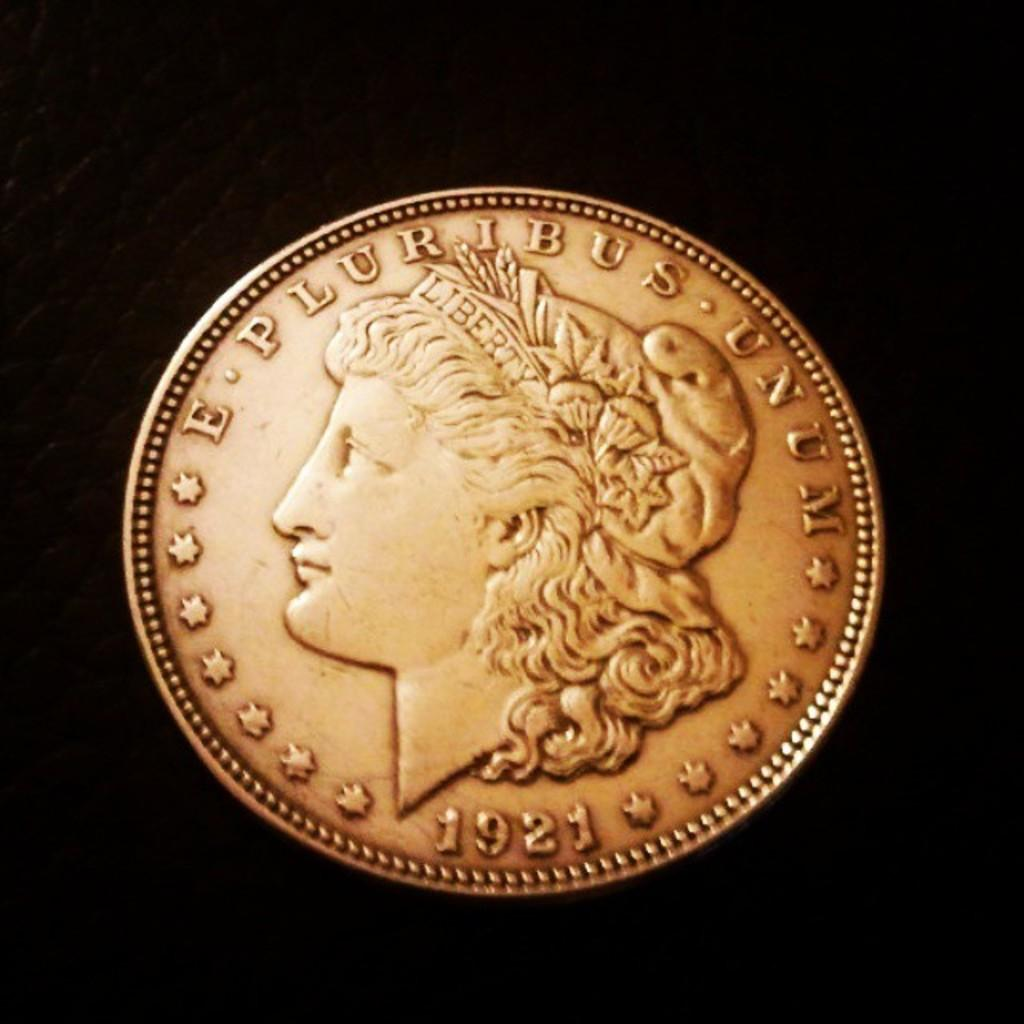Provide a one-sentence caption for the provided image. A coin from 1921 bears the phrase "E pluribus unum.". 